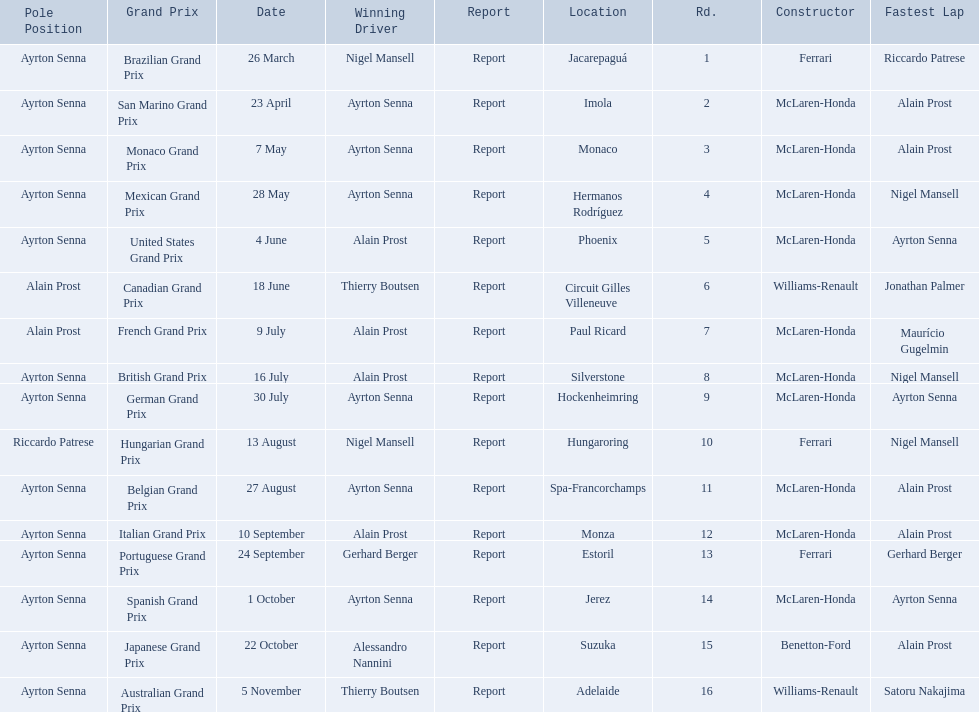Who won the spanish grand prix? McLaren-Honda. Who won the italian grand prix? McLaren-Honda. What grand prix did benneton-ford win? Japanese Grand Prix. 